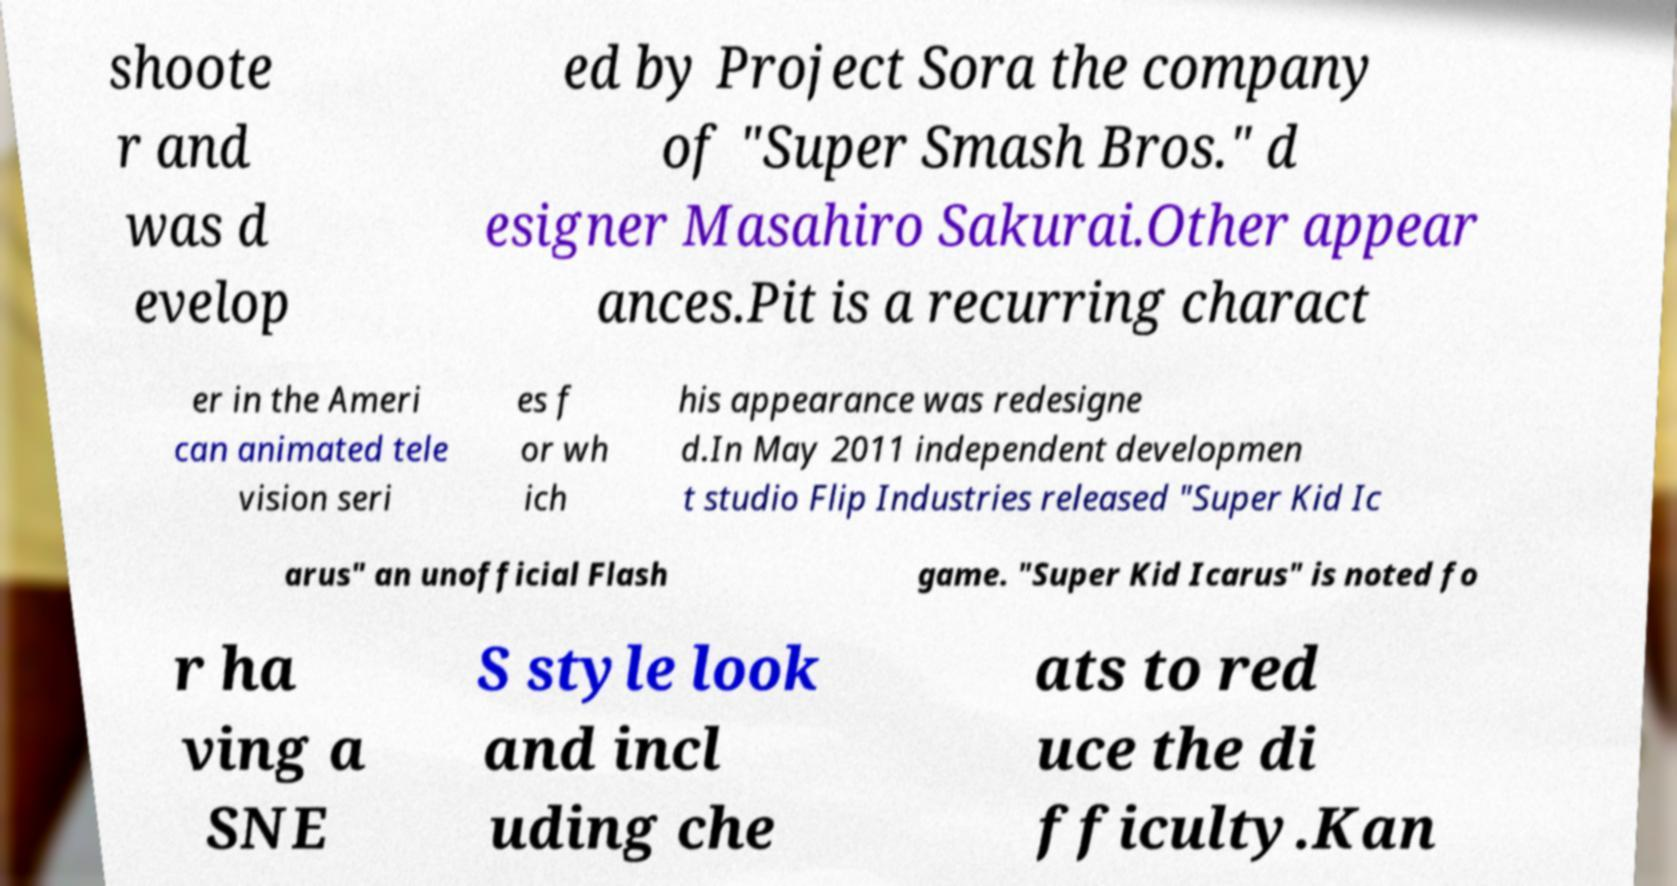Could you assist in decoding the text presented in this image and type it out clearly? shoote r and was d evelop ed by Project Sora the company of "Super Smash Bros." d esigner Masahiro Sakurai.Other appear ances.Pit is a recurring charact er in the Ameri can animated tele vision seri es f or wh ich his appearance was redesigne d.In May 2011 independent developmen t studio Flip Industries released "Super Kid Ic arus" an unofficial Flash game. "Super Kid Icarus" is noted fo r ha ving a SNE S style look and incl uding che ats to red uce the di fficulty.Kan 